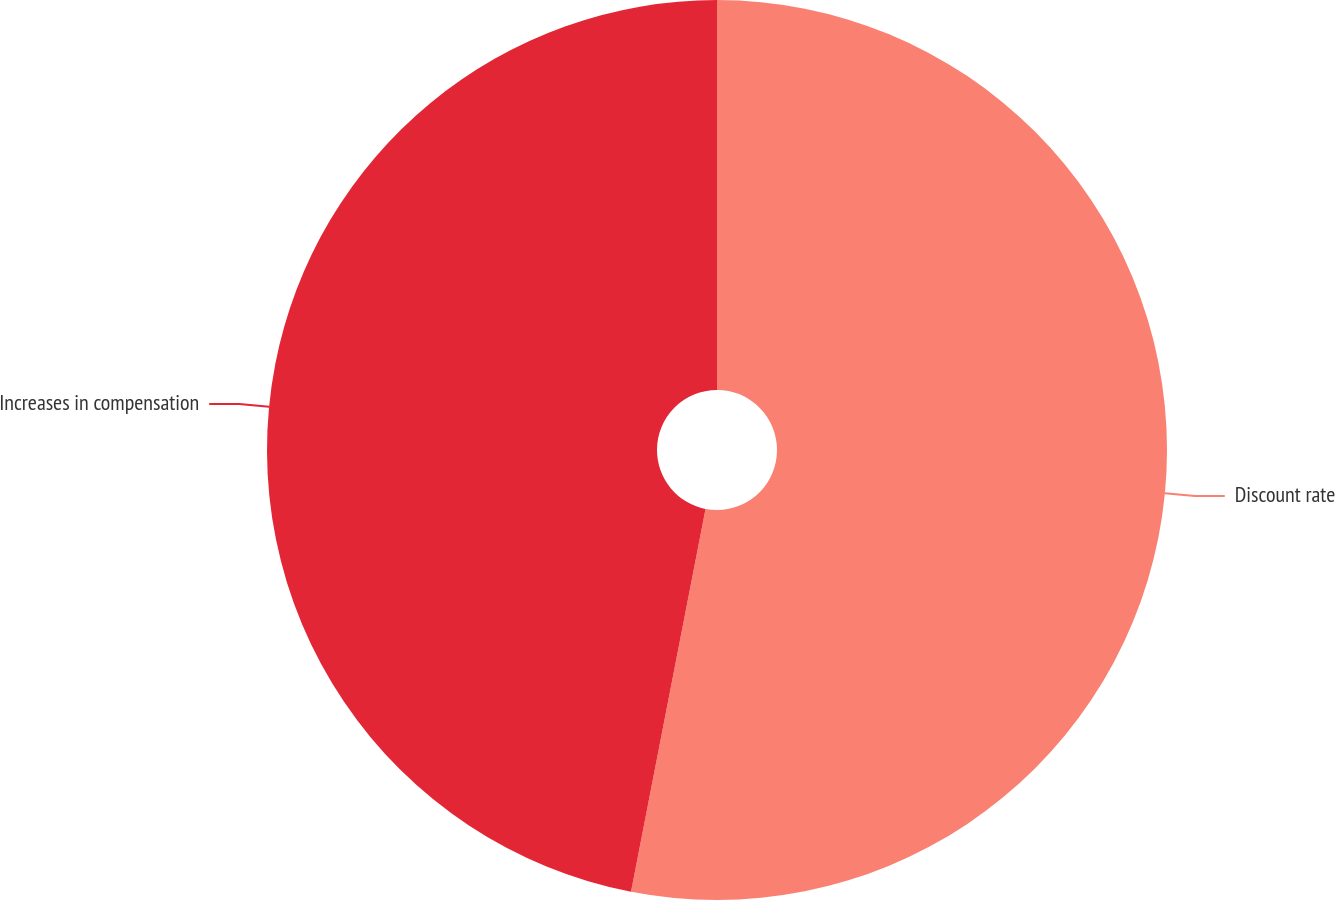<chart> <loc_0><loc_0><loc_500><loc_500><pie_chart><fcel>Discount rate<fcel>Increases in compensation<nl><fcel>53.06%<fcel>46.94%<nl></chart> 